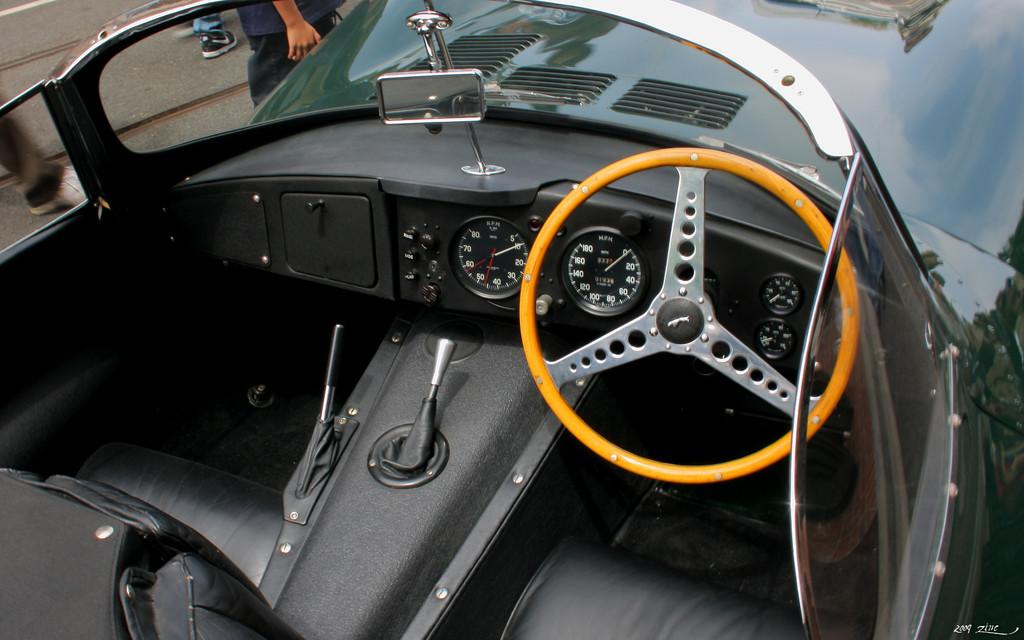What type of vehicle is in the image? There is a vehicle in the image, but the specific type is not mentioned. What features are present in the vehicle? The vehicle has a steering wheel, gauges, and a mirror. Can you describe the person visible in the image? There are legs and a person visible in the left side corner of the image. What type of haircut does the vehicle have in the image? The vehicle does not have a haircut, as it is an inanimate object and cannot have a haircut. 